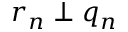Convert formula to latex. <formula><loc_0><loc_0><loc_500><loc_500>r _ { n } \perp q _ { n }</formula> 